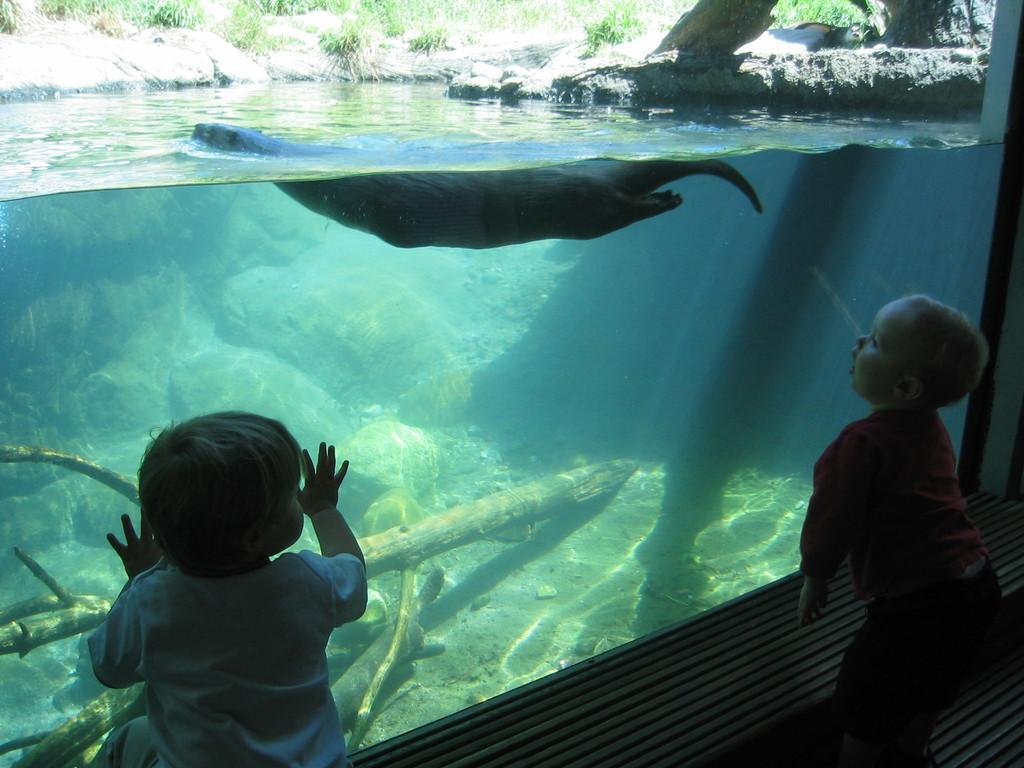How many kids are standing in the image? There are two kids standing in the image. What is the aquarium-like object in the image? There is an aquarium-like object in the image. What animal can be seen in the aquarium-like object? A manatee is visible in the image. What type of natural surface is present in the image? There are stones and grass in the image. What type of mine is visible in the image? There is no mine present in the image. What error can be found in the image? There is no error present in the image. 